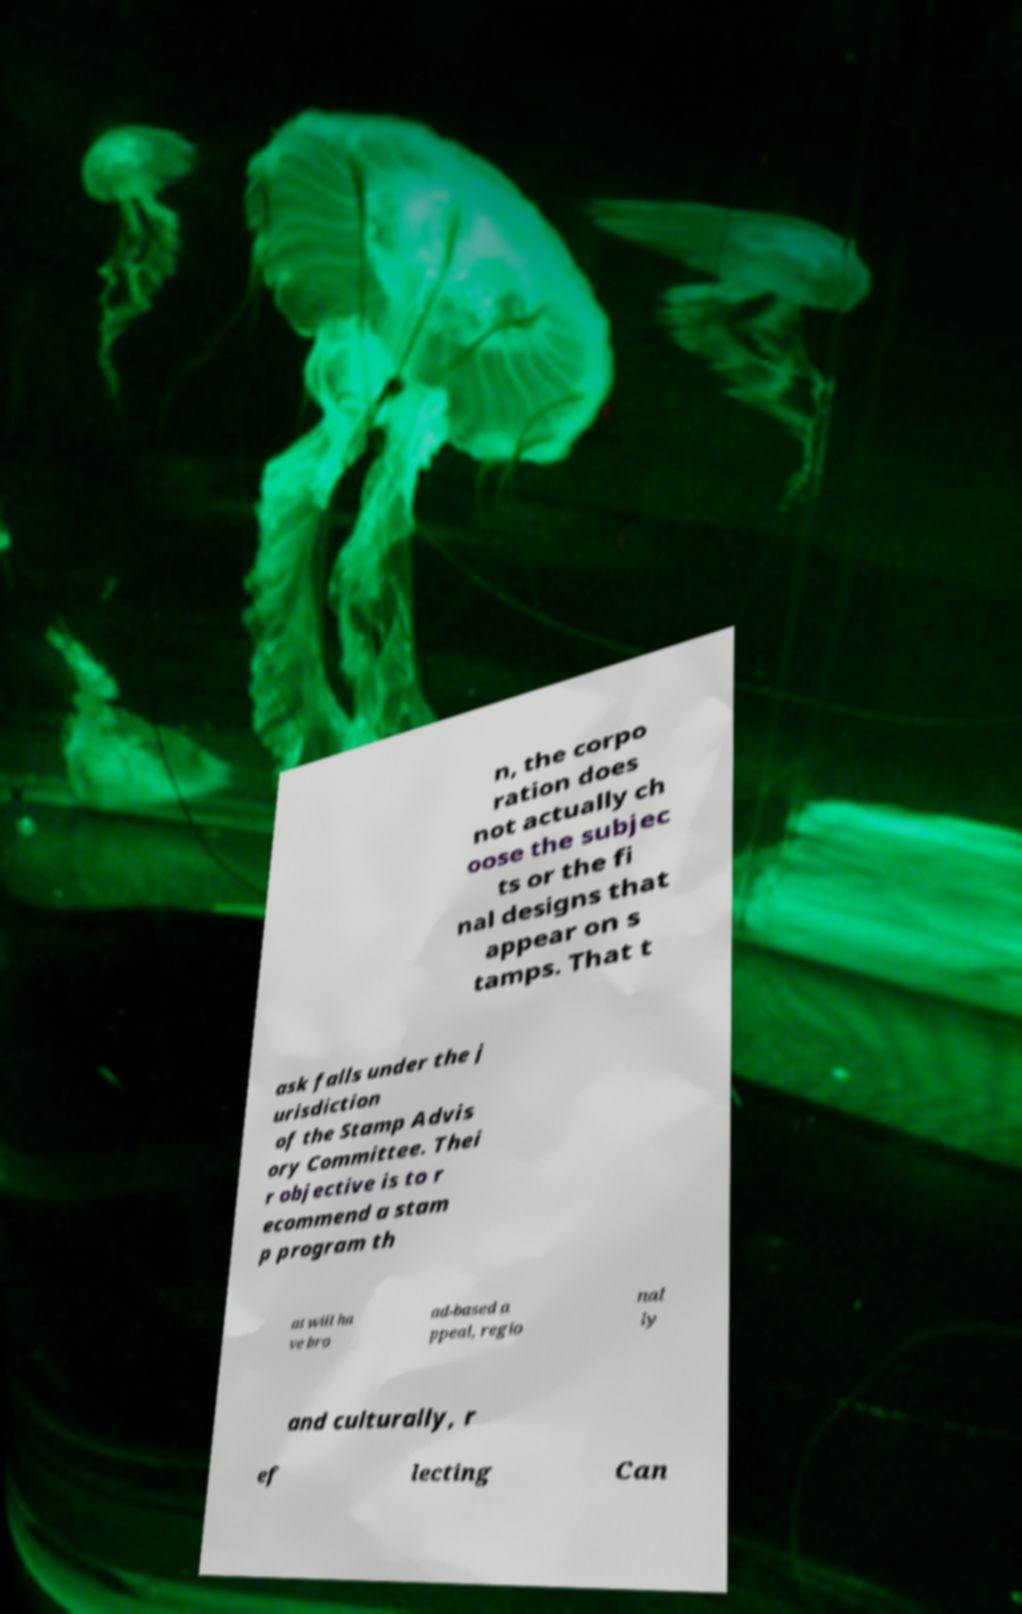What messages or text are displayed in this image? I need them in a readable, typed format. n, the corpo ration does not actually ch oose the subjec ts or the fi nal designs that appear on s tamps. That t ask falls under the j urisdiction of the Stamp Advis ory Committee. Thei r objective is to r ecommend a stam p program th at will ha ve bro ad-based a ppeal, regio nal ly and culturally, r ef lecting Can 